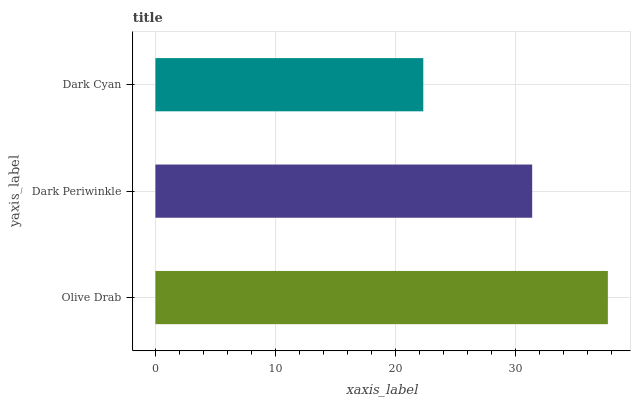Is Dark Cyan the minimum?
Answer yes or no. Yes. Is Olive Drab the maximum?
Answer yes or no. Yes. Is Dark Periwinkle the minimum?
Answer yes or no. No. Is Dark Periwinkle the maximum?
Answer yes or no. No. Is Olive Drab greater than Dark Periwinkle?
Answer yes or no. Yes. Is Dark Periwinkle less than Olive Drab?
Answer yes or no. Yes. Is Dark Periwinkle greater than Olive Drab?
Answer yes or no. No. Is Olive Drab less than Dark Periwinkle?
Answer yes or no. No. Is Dark Periwinkle the high median?
Answer yes or no. Yes. Is Dark Periwinkle the low median?
Answer yes or no. Yes. Is Olive Drab the high median?
Answer yes or no. No. Is Dark Cyan the low median?
Answer yes or no. No. 